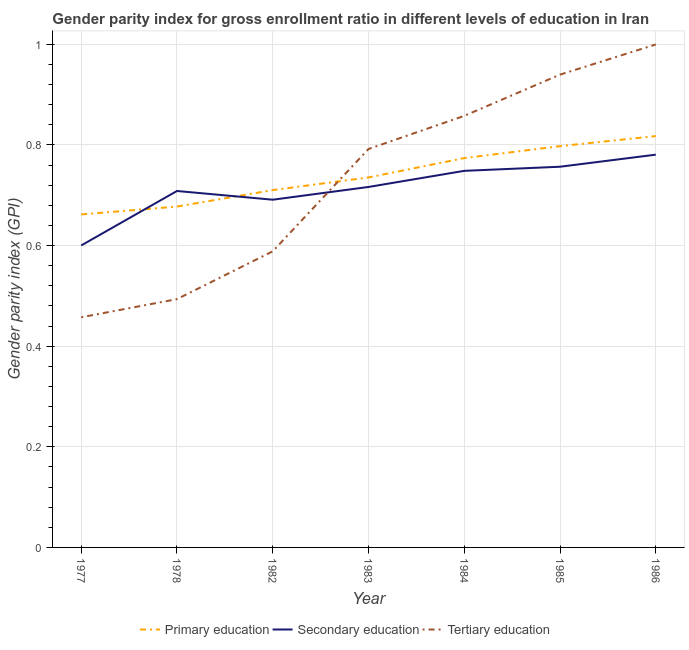Does the line corresponding to gender parity index in secondary education intersect with the line corresponding to gender parity index in primary education?
Your answer should be compact. Yes. Is the number of lines equal to the number of legend labels?
Provide a succinct answer. Yes. What is the gender parity index in primary education in 1983?
Your answer should be very brief. 0.74. Across all years, what is the maximum gender parity index in tertiary education?
Provide a short and direct response. 1. Across all years, what is the minimum gender parity index in primary education?
Your response must be concise. 0.66. In which year was the gender parity index in primary education minimum?
Provide a short and direct response. 1977. What is the total gender parity index in secondary education in the graph?
Offer a very short reply. 5. What is the difference between the gender parity index in tertiary education in 1982 and that in 1985?
Provide a succinct answer. -0.35. What is the difference between the gender parity index in secondary education in 1984 and the gender parity index in tertiary education in 1982?
Your response must be concise. 0.16. What is the average gender parity index in secondary education per year?
Your answer should be very brief. 0.71. In the year 1977, what is the difference between the gender parity index in primary education and gender parity index in tertiary education?
Your answer should be very brief. 0.2. In how many years, is the gender parity index in tertiary education greater than 0.7600000000000001?
Your answer should be compact. 4. What is the ratio of the gender parity index in primary education in 1985 to that in 1986?
Offer a very short reply. 0.98. Is the gender parity index in secondary education in 1984 less than that in 1985?
Your response must be concise. Yes. Is the difference between the gender parity index in secondary education in 1977 and 1984 greater than the difference between the gender parity index in tertiary education in 1977 and 1984?
Offer a terse response. Yes. What is the difference between the highest and the second highest gender parity index in tertiary education?
Your response must be concise. 0.06. What is the difference between the highest and the lowest gender parity index in primary education?
Make the answer very short. 0.16. Is the sum of the gender parity index in primary education in 1978 and 1984 greater than the maximum gender parity index in tertiary education across all years?
Ensure brevity in your answer.  Yes. Does the gender parity index in tertiary education monotonically increase over the years?
Offer a terse response. Yes. Is the gender parity index in primary education strictly less than the gender parity index in tertiary education over the years?
Keep it short and to the point. No. How many lines are there?
Provide a short and direct response. 3. How many years are there in the graph?
Your answer should be very brief. 7. Does the graph contain any zero values?
Make the answer very short. No. Where does the legend appear in the graph?
Ensure brevity in your answer.  Bottom center. How many legend labels are there?
Your answer should be very brief. 3. How are the legend labels stacked?
Your response must be concise. Horizontal. What is the title of the graph?
Offer a terse response. Gender parity index for gross enrollment ratio in different levels of education in Iran. Does "Ages 0-14" appear as one of the legend labels in the graph?
Provide a succinct answer. No. What is the label or title of the Y-axis?
Keep it short and to the point. Gender parity index (GPI). What is the Gender parity index (GPI) of Primary education in 1977?
Provide a succinct answer. 0.66. What is the Gender parity index (GPI) of Secondary education in 1977?
Your answer should be compact. 0.6. What is the Gender parity index (GPI) in Tertiary education in 1977?
Keep it short and to the point. 0.46. What is the Gender parity index (GPI) in Primary education in 1978?
Your response must be concise. 0.68. What is the Gender parity index (GPI) of Secondary education in 1978?
Your answer should be compact. 0.71. What is the Gender parity index (GPI) in Tertiary education in 1978?
Ensure brevity in your answer.  0.49. What is the Gender parity index (GPI) of Primary education in 1982?
Offer a very short reply. 0.71. What is the Gender parity index (GPI) in Secondary education in 1982?
Make the answer very short. 0.69. What is the Gender parity index (GPI) in Tertiary education in 1982?
Your answer should be compact. 0.59. What is the Gender parity index (GPI) of Primary education in 1983?
Provide a succinct answer. 0.74. What is the Gender parity index (GPI) in Secondary education in 1983?
Your response must be concise. 0.72. What is the Gender parity index (GPI) in Tertiary education in 1983?
Your answer should be compact. 0.79. What is the Gender parity index (GPI) of Primary education in 1984?
Give a very brief answer. 0.77. What is the Gender parity index (GPI) of Secondary education in 1984?
Provide a succinct answer. 0.75. What is the Gender parity index (GPI) in Tertiary education in 1984?
Make the answer very short. 0.86. What is the Gender parity index (GPI) in Primary education in 1985?
Provide a short and direct response. 0.8. What is the Gender parity index (GPI) of Secondary education in 1985?
Offer a very short reply. 0.76. What is the Gender parity index (GPI) in Tertiary education in 1985?
Your response must be concise. 0.94. What is the Gender parity index (GPI) in Primary education in 1986?
Provide a succinct answer. 0.82. What is the Gender parity index (GPI) in Secondary education in 1986?
Offer a terse response. 0.78. What is the Gender parity index (GPI) in Tertiary education in 1986?
Keep it short and to the point. 1. Across all years, what is the maximum Gender parity index (GPI) in Primary education?
Ensure brevity in your answer.  0.82. Across all years, what is the maximum Gender parity index (GPI) in Secondary education?
Your answer should be compact. 0.78. Across all years, what is the maximum Gender parity index (GPI) in Tertiary education?
Provide a succinct answer. 1. Across all years, what is the minimum Gender parity index (GPI) in Primary education?
Offer a terse response. 0.66. Across all years, what is the minimum Gender parity index (GPI) of Secondary education?
Your answer should be compact. 0.6. Across all years, what is the minimum Gender parity index (GPI) of Tertiary education?
Offer a terse response. 0.46. What is the total Gender parity index (GPI) in Primary education in the graph?
Give a very brief answer. 5.17. What is the total Gender parity index (GPI) of Secondary education in the graph?
Offer a very short reply. 5. What is the total Gender parity index (GPI) in Tertiary education in the graph?
Provide a succinct answer. 5.13. What is the difference between the Gender parity index (GPI) in Primary education in 1977 and that in 1978?
Give a very brief answer. -0.02. What is the difference between the Gender parity index (GPI) in Secondary education in 1977 and that in 1978?
Your answer should be compact. -0.11. What is the difference between the Gender parity index (GPI) of Tertiary education in 1977 and that in 1978?
Your answer should be very brief. -0.04. What is the difference between the Gender parity index (GPI) in Primary education in 1977 and that in 1982?
Provide a succinct answer. -0.05. What is the difference between the Gender parity index (GPI) in Secondary education in 1977 and that in 1982?
Ensure brevity in your answer.  -0.09. What is the difference between the Gender parity index (GPI) in Tertiary education in 1977 and that in 1982?
Your response must be concise. -0.13. What is the difference between the Gender parity index (GPI) in Primary education in 1977 and that in 1983?
Keep it short and to the point. -0.07. What is the difference between the Gender parity index (GPI) in Secondary education in 1977 and that in 1983?
Offer a very short reply. -0.12. What is the difference between the Gender parity index (GPI) of Tertiary education in 1977 and that in 1983?
Give a very brief answer. -0.33. What is the difference between the Gender parity index (GPI) in Primary education in 1977 and that in 1984?
Offer a terse response. -0.11. What is the difference between the Gender parity index (GPI) in Secondary education in 1977 and that in 1984?
Give a very brief answer. -0.15. What is the difference between the Gender parity index (GPI) in Tertiary education in 1977 and that in 1984?
Offer a terse response. -0.4. What is the difference between the Gender parity index (GPI) of Primary education in 1977 and that in 1985?
Make the answer very short. -0.14. What is the difference between the Gender parity index (GPI) of Secondary education in 1977 and that in 1985?
Offer a terse response. -0.16. What is the difference between the Gender parity index (GPI) of Tertiary education in 1977 and that in 1985?
Provide a short and direct response. -0.48. What is the difference between the Gender parity index (GPI) in Primary education in 1977 and that in 1986?
Ensure brevity in your answer.  -0.16. What is the difference between the Gender parity index (GPI) in Secondary education in 1977 and that in 1986?
Your response must be concise. -0.18. What is the difference between the Gender parity index (GPI) of Tertiary education in 1977 and that in 1986?
Make the answer very short. -0.54. What is the difference between the Gender parity index (GPI) of Primary education in 1978 and that in 1982?
Offer a very short reply. -0.03. What is the difference between the Gender parity index (GPI) in Secondary education in 1978 and that in 1982?
Ensure brevity in your answer.  0.02. What is the difference between the Gender parity index (GPI) in Tertiary education in 1978 and that in 1982?
Your answer should be very brief. -0.1. What is the difference between the Gender parity index (GPI) of Primary education in 1978 and that in 1983?
Keep it short and to the point. -0.06. What is the difference between the Gender parity index (GPI) of Secondary education in 1978 and that in 1983?
Ensure brevity in your answer.  -0.01. What is the difference between the Gender parity index (GPI) of Tertiary education in 1978 and that in 1983?
Your answer should be very brief. -0.3. What is the difference between the Gender parity index (GPI) of Primary education in 1978 and that in 1984?
Give a very brief answer. -0.1. What is the difference between the Gender parity index (GPI) of Secondary education in 1978 and that in 1984?
Your response must be concise. -0.04. What is the difference between the Gender parity index (GPI) in Tertiary education in 1978 and that in 1984?
Your response must be concise. -0.36. What is the difference between the Gender parity index (GPI) of Primary education in 1978 and that in 1985?
Give a very brief answer. -0.12. What is the difference between the Gender parity index (GPI) of Secondary education in 1978 and that in 1985?
Offer a terse response. -0.05. What is the difference between the Gender parity index (GPI) of Tertiary education in 1978 and that in 1985?
Ensure brevity in your answer.  -0.45. What is the difference between the Gender parity index (GPI) in Primary education in 1978 and that in 1986?
Your answer should be compact. -0.14. What is the difference between the Gender parity index (GPI) in Secondary education in 1978 and that in 1986?
Offer a terse response. -0.07. What is the difference between the Gender parity index (GPI) of Tertiary education in 1978 and that in 1986?
Keep it short and to the point. -0.51. What is the difference between the Gender parity index (GPI) in Primary education in 1982 and that in 1983?
Offer a very short reply. -0.03. What is the difference between the Gender parity index (GPI) in Secondary education in 1982 and that in 1983?
Provide a succinct answer. -0.03. What is the difference between the Gender parity index (GPI) in Tertiary education in 1982 and that in 1983?
Offer a very short reply. -0.2. What is the difference between the Gender parity index (GPI) of Primary education in 1982 and that in 1984?
Your answer should be compact. -0.06. What is the difference between the Gender parity index (GPI) in Secondary education in 1982 and that in 1984?
Make the answer very short. -0.06. What is the difference between the Gender parity index (GPI) in Tertiary education in 1982 and that in 1984?
Offer a very short reply. -0.27. What is the difference between the Gender parity index (GPI) in Primary education in 1982 and that in 1985?
Your answer should be compact. -0.09. What is the difference between the Gender parity index (GPI) of Secondary education in 1982 and that in 1985?
Provide a short and direct response. -0.07. What is the difference between the Gender parity index (GPI) of Tertiary education in 1982 and that in 1985?
Offer a very short reply. -0.35. What is the difference between the Gender parity index (GPI) in Primary education in 1982 and that in 1986?
Your answer should be very brief. -0.11. What is the difference between the Gender parity index (GPI) of Secondary education in 1982 and that in 1986?
Provide a succinct answer. -0.09. What is the difference between the Gender parity index (GPI) of Tertiary education in 1982 and that in 1986?
Provide a short and direct response. -0.41. What is the difference between the Gender parity index (GPI) of Primary education in 1983 and that in 1984?
Offer a terse response. -0.04. What is the difference between the Gender parity index (GPI) in Secondary education in 1983 and that in 1984?
Offer a terse response. -0.03. What is the difference between the Gender parity index (GPI) of Tertiary education in 1983 and that in 1984?
Make the answer very short. -0.07. What is the difference between the Gender parity index (GPI) of Primary education in 1983 and that in 1985?
Your answer should be compact. -0.06. What is the difference between the Gender parity index (GPI) in Secondary education in 1983 and that in 1985?
Offer a terse response. -0.04. What is the difference between the Gender parity index (GPI) of Tertiary education in 1983 and that in 1985?
Your answer should be very brief. -0.15. What is the difference between the Gender parity index (GPI) of Primary education in 1983 and that in 1986?
Give a very brief answer. -0.08. What is the difference between the Gender parity index (GPI) in Secondary education in 1983 and that in 1986?
Make the answer very short. -0.06. What is the difference between the Gender parity index (GPI) of Tertiary education in 1983 and that in 1986?
Keep it short and to the point. -0.21. What is the difference between the Gender parity index (GPI) in Primary education in 1984 and that in 1985?
Offer a very short reply. -0.02. What is the difference between the Gender parity index (GPI) in Secondary education in 1984 and that in 1985?
Ensure brevity in your answer.  -0.01. What is the difference between the Gender parity index (GPI) in Tertiary education in 1984 and that in 1985?
Offer a terse response. -0.08. What is the difference between the Gender parity index (GPI) of Primary education in 1984 and that in 1986?
Ensure brevity in your answer.  -0.04. What is the difference between the Gender parity index (GPI) of Secondary education in 1984 and that in 1986?
Provide a short and direct response. -0.03. What is the difference between the Gender parity index (GPI) in Tertiary education in 1984 and that in 1986?
Give a very brief answer. -0.14. What is the difference between the Gender parity index (GPI) in Primary education in 1985 and that in 1986?
Provide a succinct answer. -0.02. What is the difference between the Gender parity index (GPI) in Secondary education in 1985 and that in 1986?
Make the answer very short. -0.02. What is the difference between the Gender parity index (GPI) in Tertiary education in 1985 and that in 1986?
Your answer should be very brief. -0.06. What is the difference between the Gender parity index (GPI) in Primary education in 1977 and the Gender parity index (GPI) in Secondary education in 1978?
Give a very brief answer. -0.05. What is the difference between the Gender parity index (GPI) in Primary education in 1977 and the Gender parity index (GPI) in Tertiary education in 1978?
Your answer should be very brief. 0.17. What is the difference between the Gender parity index (GPI) of Secondary education in 1977 and the Gender parity index (GPI) of Tertiary education in 1978?
Offer a very short reply. 0.11. What is the difference between the Gender parity index (GPI) of Primary education in 1977 and the Gender parity index (GPI) of Secondary education in 1982?
Your answer should be very brief. -0.03. What is the difference between the Gender parity index (GPI) of Primary education in 1977 and the Gender parity index (GPI) of Tertiary education in 1982?
Offer a terse response. 0.07. What is the difference between the Gender parity index (GPI) of Secondary education in 1977 and the Gender parity index (GPI) of Tertiary education in 1982?
Offer a very short reply. 0.01. What is the difference between the Gender parity index (GPI) of Primary education in 1977 and the Gender parity index (GPI) of Secondary education in 1983?
Offer a very short reply. -0.05. What is the difference between the Gender parity index (GPI) in Primary education in 1977 and the Gender parity index (GPI) in Tertiary education in 1983?
Provide a short and direct response. -0.13. What is the difference between the Gender parity index (GPI) in Secondary education in 1977 and the Gender parity index (GPI) in Tertiary education in 1983?
Give a very brief answer. -0.19. What is the difference between the Gender parity index (GPI) of Primary education in 1977 and the Gender parity index (GPI) of Secondary education in 1984?
Offer a very short reply. -0.09. What is the difference between the Gender parity index (GPI) of Primary education in 1977 and the Gender parity index (GPI) of Tertiary education in 1984?
Your answer should be compact. -0.2. What is the difference between the Gender parity index (GPI) of Secondary education in 1977 and the Gender parity index (GPI) of Tertiary education in 1984?
Your response must be concise. -0.26. What is the difference between the Gender parity index (GPI) of Primary education in 1977 and the Gender parity index (GPI) of Secondary education in 1985?
Keep it short and to the point. -0.09. What is the difference between the Gender parity index (GPI) of Primary education in 1977 and the Gender parity index (GPI) of Tertiary education in 1985?
Give a very brief answer. -0.28. What is the difference between the Gender parity index (GPI) in Secondary education in 1977 and the Gender parity index (GPI) in Tertiary education in 1985?
Your answer should be compact. -0.34. What is the difference between the Gender parity index (GPI) in Primary education in 1977 and the Gender parity index (GPI) in Secondary education in 1986?
Provide a succinct answer. -0.12. What is the difference between the Gender parity index (GPI) in Primary education in 1977 and the Gender parity index (GPI) in Tertiary education in 1986?
Offer a very short reply. -0.34. What is the difference between the Gender parity index (GPI) of Secondary education in 1977 and the Gender parity index (GPI) of Tertiary education in 1986?
Keep it short and to the point. -0.4. What is the difference between the Gender parity index (GPI) in Primary education in 1978 and the Gender parity index (GPI) in Secondary education in 1982?
Make the answer very short. -0.01. What is the difference between the Gender parity index (GPI) of Primary education in 1978 and the Gender parity index (GPI) of Tertiary education in 1982?
Provide a short and direct response. 0.09. What is the difference between the Gender parity index (GPI) in Secondary education in 1978 and the Gender parity index (GPI) in Tertiary education in 1982?
Provide a succinct answer. 0.12. What is the difference between the Gender parity index (GPI) in Primary education in 1978 and the Gender parity index (GPI) in Secondary education in 1983?
Offer a terse response. -0.04. What is the difference between the Gender parity index (GPI) in Primary education in 1978 and the Gender parity index (GPI) in Tertiary education in 1983?
Provide a short and direct response. -0.11. What is the difference between the Gender parity index (GPI) of Secondary education in 1978 and the Gender parity index (GPI) of Tertiary education in 1983?
Your response must be concise. -0.08. What is the difference between the Gender parity index (GPI) of Primary education in 1978 and the Gender parity index (GPI) of Secondary education in 1984?
Your answer should be very brief. -0.07. What is the difference between the Gender parity index (GPI) of Primary education in 1978 and the Gender parity index (GPI) of Tertiary education in 1984?
Your answer should be very brief. -0.18. What is the difference between the Gender parity index (GPI) of Secondary education in 1978 and the Gender parity index (GPI) of Tertiary education in 1984?
Offer a terse response. -0.15. What is the difference between the Gender parity index (GPI) of Primary education in 1978 and the Gender parity index (GPI) of Secondary education in 1985?
Your answer should be compact. -0.08. What is the difference between the Gender parity index (GPI) in Primary education in 1978 and the Gender parity index (GPI) in Tertiary education in 1985?
Keep it short and to the point. -0.26. What is the difference between the Gender parity index (GPI) in Secondary education in 1978 and the Gender parity index (GPI) in Tertiary education in 1985?
Ensure brevity in your answer.  -0.23. What is the difference between the Gender parity index (GPI) in Primary education in 1978 and the Gender parity index (GPI) in Secondary education in 1986?
Your answer should be compact. -0.1. What is the difference between the Gender parity index (GPI) in Primary education in 1978 and the Gender parity index (GPI) in Tertiary education in 1986?
Provide a short and direct response. -0.32. What is the difference between the Gender parity index (GPI) in Secondary education in 1978 and the Gender parity index (GPI) in Tertiary education in 1986?
Make the answer very short. -0.29. What is the difference between the Gender parity index (GPI) in Primary education in 1982 and the Gender parity index (GPI) in Secondary education in 1983?
Offer a very short reply. -0.01. What is the difference between the Gender parity index (GPI) in Primary education in 1982 and the Gender parity index (GPI) in Tertiary education in 1983?
Your response must be concise. -0.08. What is the difference between the Gender parity index (GPI) in Secondary education in 1982 and the Gender parity index (GPI) in Tertiary education in 1983?
Your answer should be compact. -0.1. What is the difference between the Gender parity index (GPI) in Primary education in 1982 and the Gender parity index (GPI) in Secondary education in 1984?
Provide a short and direct response. -0.04. What is the difference between the Gender parity index (GPI) in Primary education in 1982 and the Gender parity index (GPI) in Tertiary education in 1984?
Provide a succinct answer. -0.15. What is the difference between the Gender parity index (GPI) of Secondary education in 1982 and the Gender parity index (GPI) of Tertiary education in 1984?
Your answer should be very brief. -0.17. What is the difference between the Gender parity index (GPI) of Primary education in 1982 and the Gender parity index (GPI) of Secondary education in 1985?
Offer a terse response. -0.05. What is the difference between the Gender parity index (GPI) in Primary education in 1982 and the Gender parity index (GPI) in Tertiary education in 1985?
Ensure brevity in your answer.  -0.23. What is the difference between the Gender parity index (GPI) of Secondary education in 1982 and the Gender parity index (GPI) of Tertiary education in 1985?
Provide a short and direct response. -0.25. What is the difference between the Gender parity index (GPI) in Primary education in 1982 and the Gender parity index (GPI) in Secondary education in 1986?
Ensure brevity in your answer.  -0.07. What is the difference between the Gender parity index (GPI) in Primary education in 1982 and the Gender parity index (GPI) in Tertiary education in 1986?
Your answer should be very brief. -0.29. What is the difference between the Gender parity index (GPI) in Secondary education in 1982 and the Gender parity index (GPI) in Tertiary education in 1986?
Provide a succinct answer. -0.31. What is the difference between the Gender parity index (GPI) of Primary education in 1983 and the Gender parity index (GPI) of Secondary education in 1984?
Your response must be concise. -0.01. What is the difference between the Gender parity index (GPI) of Primary education in 1983 and the Gender parity index (GPI) of Tertiary education in 1984?
Keep it short and to the point. -0.12. What is the difference between the Gender parity index (GPI) in Secondary education in 1983 and the Gender parity index (GPI) in Tertiary education in 1984?
Keep it short and to the point. -0.14. What is the difference between the Gender parity index (GPI) in Primary education in 1983 and the Gender parity index (GPI) in Secondary education in 1985?
Your response must be concise. -0.02. What is the difference between the Gender parity index (GPI) of Primary education in 1983 and the Gender parity index (GPI) of Tertiary education in 1985?
Ensure brevity in your answer.  -0.2. What is the difference between the Gender parity index (GPI) in Secondary education in 1983 and the Gender parity index (GPI) in Tertiary education in 1985?
Make the answer very short. -0.22. What is the difference between the Gender parity index (GPI) in Primary education in 1983 and the Gender parity index (GPI) in Secondary education in 1986?
Provide a short and direct response. -0.05. What is the difference between the Gender parity index (GPI) of Primary education in 1983 and the Gender parity index (GPI) of Tertiary education in 1986?
Ensure brevity in your answer.  -0.26. What is the difference between the Gender parity index (GPI) of Secondary education in 1983 and the Gender parity index (GPI) of Tertiary education in 1986?
Your answer should be very brief. -0.28. What is the difference between the Gender parity index (GPI) of Primary education in 1984 and the Gender parity index (GPI) of Secondary education in 1985?
Offer a terse response. 0.02. What is the difference between the Gender parity index (GPI) in Primary education in 1984 and the Gender parity index (GPI) in Tertiary education in 1985?
Your answer should be very brief. -0.17. What is the difference between the Gender parity index (GPI) in Secondary education in 1984 and the Gender parity index (GPI) in Tertiary education in 1985?
Provide a short and direct response. -0.19. What is the difference between the Gender parity index (GPI) of Primary education in 1984 and the Gender parity index (GPI) of Secondary education in 1986?
Your answer should be very brief. -0.01. What is the difference between the Gender parity index (GPI) in Primary education in 1984 and the Gender parity index (GPI) in Tertiary education in 1986?
Offer a terse response. -0.23. What is the difference between the Gender parity index (GPI) in Secondary education in 1984 and the Gender parity index (GPI) in Tertiary education in 1986?
Your answer should be compact. -0.25. What is the difference between the Gender parity index (GPI) of Primary education in 1985 and the Gender parity index (GPI) of Secondary education in 1986?
Your answer should be very brief. 0.02. What is the difference between the Gender parity index (GPI) of Primary education in 1985 and the Gender parity index (GPI) of Tertiary education in 1986?
Provide a short and direct response. -0.2. What is the difference between the Gender parity index (GPI) in Secondary education in 1985 and the Gender parity index (GPI) in Tertiary education in 1986?
Make the answer very short. -0.24. What is the average Gender parity index (GPI) in Primary education per year?
Provide a short and direct response. 0.74. What is the average Gender parity index (GPI) of Secondary education per year?
Offer a very short reply. 0.71. What is the average Gender parity index (GPI) of Tertiary education per year?
Your response must be concise. 0.73. In the year 1977, what is the difference between the Gender parity index (GPI) of Primary education and Gender parity index (GPI) of Secondary education?
Keep it short and to the point. 0.06. In the year 1977, what is the difference between the Gender parity index (GPI) of Primary education and Gender parity index (GPI) of Tertiary education?
Your answer should be very brief. 0.2. In the year 1977, what is the difference between the Gender parity index (GPI) of Secondary education and Gender parity index (GPI) of Tertiary education?
Your response must be concise. 0.14. In the year 1978, what is the difference between the Gender parity index (GPI) of Primary education and Gender parity index (GPI) of Secondary education?
Give a very brief answer. -0.03. In the year 1978, what is the difference between the Gender parity index (GPI) of Primary education and Gender parity index (GPI) of Tertiary education?
Provide a short and direct response. 0.18. In the year 1978, what is the difference between the Gender parity index (GPI) of Secondary education and Gender parity index (GPI) of Tertiary education?
Give a very brief answer. 0.21. In the year 1982, what is the difference between the Gender parity index (GPI) in Primary education and Gender parity index (GPI) in Secondary education?
Give a very brief answer. 0.02. In the year 1982, what is the difference between the Gender parity index (GPI) in Primary education and Gender parity index (GPI) in Tertiary education?
Ensure brevity in your answer.  0.12. In the year 1982, what is the difference between the Gender parity index (GPI) of Secondary education and Gender parity index (GPI) of Tertiary education?
Your answer should be very brief. 0.1. In the year 1983, what is the difference between the Gender parity index (GPI) of Primary education and Gender parity index (GPI) of Secondary education?
Provide a short and direct response. 0.02. In the year 1983, what is the difference between the Gender parity index (GPI) in Primary education and Gender parity index (GPI) in Tertiary education?
Give a very brief answer. -0.06. In the year 1983, what is the difference between the Gender parity index (GPI) of Secondary education and Gender parity index (GPI) of Tertiary education?
Ensure brevity in your answer.  -0.08. In the year 1984, what is the difference between the Gender parity index (GPI) of Primary education and Gender parity index (GPI) of Secondary education?
Offer a very short reply. 0.03. In the year 1984, what is the difference between the Gender parity index (GPI) in Primary education and Gender parity index (GPI) in Tertiary education?
Your answer should be very brief. -0.08. In the year 1984, what is the difference between the Gender parity index (GPI) in Secondary education and Gender parity index (GPI) in Tertiary education?
Ensure brevity in your answer.  -0.11. In the year 1985, what is the difference between the Gender parity index (GPI) of Primary education and Gender parity index (GPI) of Secondary education?
Make the answer very short. 0.04. In the year 1985, what is the difference between the Gender parity index (GPI) in Primary education and Gender parity index (GPI) in Tertiary education?
Your answer should be compact. -0.14. In the year 1985, what is the difference between the Gender parity index (GPI) of Secondary education and Gender parity index (GPI) of Tertiary education?
Offer a very short reply. -0.18. In the year 1986, what is the difference between the Gender parity index (GPI) in Primary education and Gender parity index (GPI) in Secondary education?
Give a very brief answer. 0.04. In the year 1986, what is the difference between the Gender parity index (GPI) of Primary education and Gender parity index (GPI) of Tertiary education?
Provide a short and direct response. -0.18. In the year 1986, what is the difference between the Gender parity index (GPI) of Secondary education and Gender parity index (GPI) of Tertiary education?
Offer a terse response. -0.22. What is the ratio of the Gender parity index (GPI) of Primary education in 1977 to that in 1978?
Your response must be concise. 0.98. What is the ratio of the Gender parity index (GPI) of Secondary education in 1977 to that in 1978?
Provide a succinct answer. 0.85. What is the ratio of the Gender parity index (GPI) in Tertiary education in 1977 to that in 1978?
Offer a terse response. 0.93. What is the ratio of the Gender parity index (GPI) of Primary education in 1977 to that in 1982?
Your answer should be very brief. 0.93. What is the ratio of the Gender parity index (GPI) in Secondary education in 1977 to that in 1982?
Your answer should be compact. 0.87. What is the ratio of the Gender parity index (GPI) of Tertiary education in 1977 to that in 1982?
Offer a very short reply. 0.78. What is the ratio of the Gender parity index (GPI) in Secondary education in 1977 to that in 1983?
Ensure brevity in your answer.  0.84. What is the ratio of the Gender parity index (GPI) of Tertiary education in 1977 to that in 1983?
Provide a succinct answer. 0.58. What is the ratio of the Gender parity index (GPI) in Primary education in 1977 to that in 1984?
Provide a succinct answer. 0.86. What is the ratio of the Gender parity index (GPI) of Secondary education in 1977 to that in 1984?
Provide a short and direct response. 0.8. What is the ratio of the Gender parity index (GPI) in Tertiary education in 1977 to that in 1984?
Your answer should be very brief. 0.53. What is the ratio of the Gender parity index (GPI) in Primary education in 1977 to that in 1985?
Provide a succinct answer. 0.83. What is the ratio of the Gender parity index (GPI) of Secondary education in 1977 to that in 1985?
Your answer should be compact. 0.79. What is the ratio of the Gender parity index (GPI) of Tertiary education in 1977 to that in 1985?
Give a very brief answer. 0.49. What is the ratio of the Gender parity index (GPI) of Primary education in 1977 to that in 1986?
Your answer should be very brief. 0.81. What is the ratio of the Gender parity index (GPI) of Secondary education in 1977 to that in 1986?
Make the answer very short. 0.77. What is the ratio of the Gender parity index (GPI) in Tertiary education in 1977 to that in 1986?
Give a very brief answer. 0.46. What is the ratio of the Gender parity index (GPI) of Primary education in 1978 to that in 1982?
Provide a succinct answer. 0.95. What is the ratio of the Gender parity index (GPI) of Secondary education in 1978 to that in 1982?
Make the answer very short. 1.03. What is the ratio of the Gender parity index (GPI) in Tertiary education in 1978 to that in 1982?
Give a very brief answer. 0.84. What is the ratio of the Gender parity index (GPI) in Primary education in 1978 to that in 1983?
Your answer should be compact. 0.92. What is the ratio of the Gender parity index (GPI) in Tertiary education in 1978 to that in 1983?
Ensure brevity in your answer.  0.62. What is the ratio of the Gender parity index (GPI) in Primary education in 1978 to that in 1984?
Your response must be concise. 0.88. What is the ratio of the Gender parity index (GPI) in Secondary education in 1978 to that in 1984?
Provide a short and direct response. 0.95. What is the ratio of the Gender parity index (GPI) in Tertiary education in 1978 to that in 1984?
Your response must be concise. 0.58. What is the ratio of the Gender parity index (GPI) of Primary education in 1978 to that in 1985?
Your answer should be very brief. 0.85. What is the ratio of the Gender parity index (GPI) of Secondary education in 1978 to that in 1985?
Offer a very short reply. 0.94. What is the ratio of the Gender parity index (GPI) of Tertiary education in 1978 to that in 1985?
Keep it short and to the point. 0.53. What is the ratio of the Gender parity index (GPI) of Primary education in 1978 to that in 1986?
Your response must be concise. 0.83. What is the ratio of the Gender parity index (GPI) in Secondary education in 1978 to that in 1986?
Make the answer very short. 0.91. What is the ratio of the Gender parity index (GPI) in Tertiary education in 1978 to that in 1986?
Your answer should be very brief. 0.49. What is the ratio of the Gender parity index (GPI) in Primary education in 1982 to that in 1983?
Your response must be concise. 0.97. What is the ratio of the Gender parity index (GPI) of Secondary education in 1982 to that in 1983?
Keep it short and to the point. 0.96. What is the ratio of the Gender parity index (GPI) in Tertiary education in 1982 to that in 1983?
Make the answer very short. 0.74. What is the ratio of the Gender parity index (GPI) of Primary education in 1982 to that in 1984?
Provide a short and direct response. 0.92. What is the ratio of the Gender parity index (GPI) of Secondary education in 1982 to that in 1984?
Give a very brief answer. 0.92. What is the ratio of the Gender parity index (GPI) of Tertiary education in 1982 to that in 1984?
Give a very brief answer. 0.69. What is the ratio of the Gender parity index (GPI) in Primary education in 1982 to that in 1985?
Your answer should be very brief. 0.89. What is the ratio of the Gender parity index (GPI) in Secondary education in 1982 to that in 1985?
Keep it short and to the point. 0.91. What is the ratio of the Gender parity index (GPI) in Tertiary education in 1982 to that in 1985?
Offer a very short reply. 0.63. What is the ratio of the Gender parity index (GPI) in Primary education in 1982 to that in 1986?
Your answer should be compact. 0.87. What is the ratio of the Gender parity index (GPI) in Secondary education in 1982 to that in 1986?
Offer a very short reply. 0.89. What is the ratio of the Gender parity index (GPI) in Tertiary education in 1982 to that in 1986?
Offer a terse response. 0.59. What is the ratio of the Gender parity index (GPI) in Primary education in 1983 to that in 1984?
Provide a succinct answer. 0.95. What is the ratio of the Gender parity index (GPI) of Secondary education in 1983 to that in 1984?
Give a very brief answer. 0.96. What is the ratio of the Gender parity index (GPI) of Tertiary education in 1983 to that in 1984?
Offer a very short reply. 0.92. What is the ratio of the Gender parity index (GPI) of Primary education in 1983 to that in 1985?
Offer a terse response. 0.92. What is the ratio of the Gender parity index (GPI) of Secondary education in 1983 to that in 1985?
Your answer should be very brief. 0.95. What is the ratio of the Gender parity index (GPI) of Tertiary education in 1983 to that in 1985?
Provide a short and direct response. 0.84. What is the ratio of the Gender parity index (GPI) of Primary education in 1983 to that in 1986?
Your response must be concise. 0.9. What is the ratio of the Gender parity index (GPI) in Secondary education in 1983 to that in 1986?
Ensure brevity in your answer.  0.92. What is the ratio of the Gender parity index (GPI) of Tertiary education in 1983 to that in 1986?
Provide a succinct answer. 0.79. What is the ratio of the Gender parity index (GPI) in Primary education in 1984 to that in 1985?
Provide a succinct answer. 0.97. What is the ratio of the Gender parity index (GPI) of Tertiary education in 1984 to that in 1985?
Keep it short and to the point. 0.91. What is the ratio of the Gender parity index (GPI) in Primary education in 1984 to that in 1986?
Provide a short and direct response. 0.95. What is the ratio of the Gender parity index (GPI) of Secondary education in 1984 to that in 1986?
Your answer should be compact. 0.96. What is the ratio of the Gender parity index (GPI) in Tertiary education in 1984 to that in 1986?
Provide a short and direct response. 0.86. What is the ratio of the Gender parity index (GPI) in Primary education in 1985 to that in 1986?
Keep it short and to the point. 0.98. What is the ratio of the Gender parity index (GPI) of Secondary education in 1985 to that in 1986?
Ensure brevity in your answer.  0.97. What is the ratio of the Gender parity index (GPI) of Tertiary education in 1985 to that in 1986?
Provide a short and direct response. 0.94. What is the difference between the highest and the second highest Gender parity index (GPI) in Primary education?
Give a very brief answer. 0.02. What is the difference between the highest and the second highest Gender parity index (GPI) in Secondary education?
Make the answer very short. 0.02. What is the difference between the highest and the second highest Gender parity index (GPI) of Tertiary education?
Keep it short and to the point. 0.06. What is the difference between the highest and the lowest Gender parity index (GPI) in Primary education?
Your answer should be very brief. 0.16. What is the difference between the highest and the lowest Gender parity index (GPI) in Secondary education?
Your response must be concise. 0.18. What is the difference between the highest and the lowest Gender parity index (GPI) in Tertiary education?
Provide a succinct answer. 0.54. 